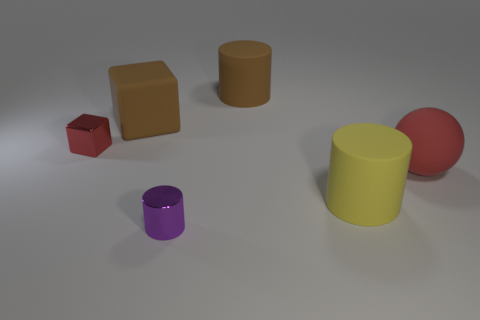Is the color of the small thing that is behind the small cylinder the same as the large matte sphere in front of the large brown cube?
Your response must be concise. Yes. Are there any other things that are the same color as the matte sphere?
Keep it short and to the point. Yes. Are any brown objects visible?
Your response must be concise. Yes. Are there any small purple metallic things right of the purple cylinder?
Your response must be concise. No. There is a purple object that is the same shape as the yellow matte thing; what is its material?
Provide a short and direct response. Metal. What number of other objects are the same shape as the yellow object?
Offer a very short reply. 2. What number of big spheres are to the left of the large brown object behind the big brown object on the left side of the purple cylinder?
Provide a short and direct response. 0. What number of gray objects are the same shape as the large yellow object?
Offer a very short reply. 0. Does the small metallic thing left of the large brown cube have the same color as the matte ball?
Your answer should be very brief. Yes. What is the shape of the small object in front of the matte cylinder in front of the rubber cylinder that is behind the tiny red shiny cube?
Your answer should be compact. Cylinder. 